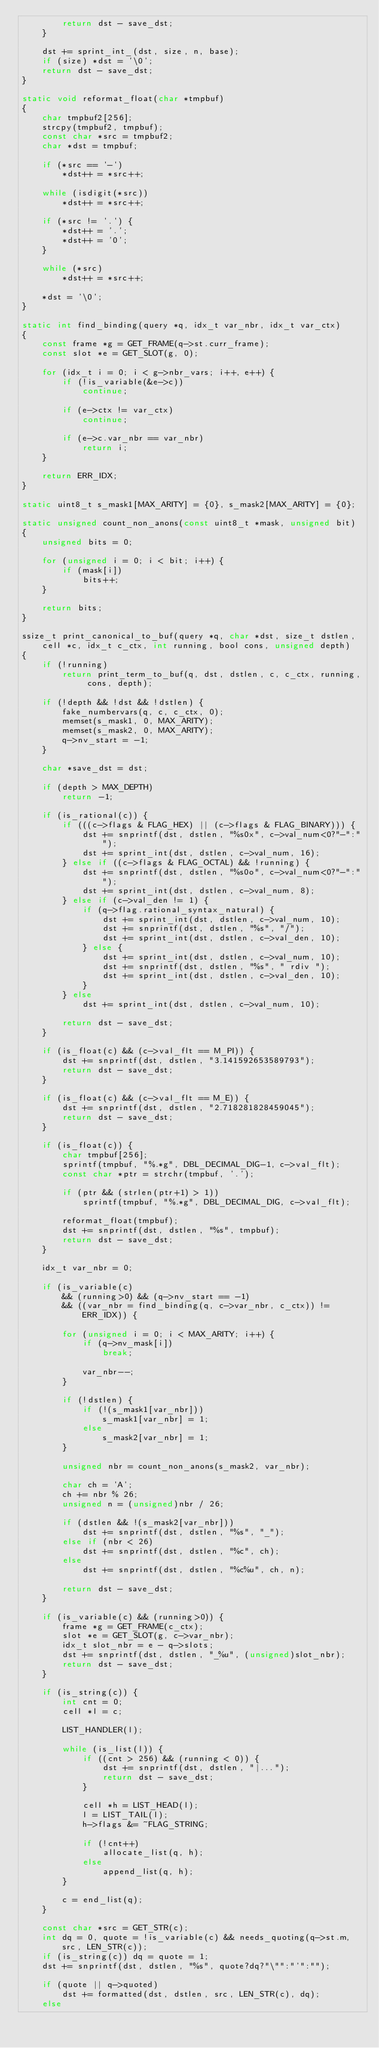<code> <loc_0><loc_0><loc_500><loc_500><_C_>		return dst - save_dst;
	}

	dst += sprint_int_(dst, size, n, base);
	if (size) *dst = '\0';
	return dst - save_dst;
}

static void reformat_float(char *tmpbuf)
{
	char tmpbuf2[256];
	strcpy(tmpbuf2, tmpbuf);
	const char *src = tmpbuf2;
	char *dst = tmpbuf;

	if (*src == '-')
		*dst++ = *src++;

	while (isdigit(*src))
		*dst++ = *src++;

	if (*src != '.') {
		*dst++ = '.';
		*dst++ = '0';
	}

	while (*src)
		*dst++ = *src++;

	*dst = '\0';
}

static int find_binding(query *q, idx_t var_nbr, idx_t var_ctx)
{
	const frame *g = GET_FRAME(q->st.curr_frame);
	const slot *e = GET_SLOT(g, 0);

	for (idx_t i = 0; i < g->nbr_vars; i++, e++) {
		if (!is_variable(&e->c))
			continue;

		if (e->ctx != var_ctx)
			continue;

		if (e->c.var_nbr == var_nbr)
			return i;
	}

	return ERR_IDX;
}

static uint8_t s_mask1[MAX_ARITY] = {0}, s_mask2[MAX_ARITY] = {0};

static unsigned count_non_anons(const uint8_t *mask, unsigned bit)
{
	unsigned bits = 0;

	for (unsigned i = 0; i < bit; i++) {
		if (mask[i])
			bits++;
	}

	return bits;
}

ssize_t print_canonical_to_buf(query *q, char *dst, size_t dstlen, cell *c, idx_t c_ctx, int running, bool cons, unsigned depth)
{
	if (!running)
		return print_term_to_buf(q, dst, dstlen, c, c_ctx, running, cons, depth);

	if (!depth && !dst && !dstlen) {
		fake_numbervars(q, c, c_ctx, 0);
		memset(s_mask1, 0, MAX_ARITY);
		memset(s_mask2, 0, MAX_ARITY);
		q->nv_start = -1;
	}

	char *save_dst = dst;

	if (depth > MAX_DEPTH)
		return -1;

	if (is_rational(c)) {
		if (((c->flags & FLAG_HEX) || (c->flags & FLAG_BINARY))) {
			dst += snprintf(dst, dstlen, "%s0x", c->val_num<0?"-":"");
			dst += sprint_int(dst, dstlen, c->val_num, 16);
		} else if ((c->flags & FLAG_OCTAL) && !running) {
			dst += snprintf(dst, dstlen, "%s0o", c->val_num<0?"-":"");
			dst += sprint_int(dst, dstlen, c->val_num, 8);
		} else if (c->val_den != 1) {
			if (q->flag.rational_syntax_natural) {
				dst += sprint_int(dst, dstlen, c->val_num, 10);
				dst += snprintf(dst, dstlen, "%s", "/");
				dst += sprint_int(dst, dstlen, c->val_den, 10);
			} else {
				dst += sprint_int(dst, dstlen, c->val_num, 10);
				dst += snprintf(dst, dstlen, "%s", " rdiv ");
				dst += sprint_int(dst, dstlen, c->val_den, 10);
			}
		} else
			dst += sprint_int(dst, dstlen, c->val_num, 10);

		return dst - save_dst;
	}

	if (is_float(c) && (c->val_flt == M_PI)) {
		dst += snprintf(dst, dstlen, "3.141592653589793");
		return dst - save_dst;
	}

	if (is_float(c) && (c->val_flt == M_E)) {
		dst += snprintf(dst, dstlen, "2.718281828459045");
		return dst - save_dst;
	}

	if (is_float(c)) {
		char tmpbuf[256];
		sprintf(tmpbuf, "%.*g", DBL_DECIMAL_DIG-1, c->val_flt);
		const char *ptr = strchr(tmpbuf, '.');

		if (ptr && (strlen(ptr+1) > 1))
			sprintf(tmpbuf, "%.*g", DBL_DECIMAL_DIG, c->val_flt);

		reformat_float(tmpbuf);
		dst += snprintf(dst, dstlen, "%s", tmpbuf);
		return dst - save_dst;
	}

	idx_t var_nbr = 0;

	if (is_variable(c)
		&& (running>0) && (q->nv_start == -1)
		&& ((var_nbr = find_binding(q, c->var_nbr, c_ctx)) != ERR_IDX)) {

		for (unsigned i = 0; i < MAX_ARITY; i++) {
			if (q->nv_mask[i])
				break;

			var_nbr--;
		}

		if (!dstlen) {
			if (!(s_mask1[var_nbr]))
				s_mask1[var_nbr] = 1;
			else
				s_mask2[var_nbr] = 1;
		}

		unsigned nbr = count_non_anons(s_mask2, var_nbr);

		char ch = 'A';
		ch += nbr % 26;
		unsigned n = (unsigned)nbr / 26;

		if (dstlen && !(s_mask2[var_nbr]))
			dst += snprintf(dst, dstlen, "%s", "_");
		else if (nbr < 26)
			dst += snprintf(dst, dstlen, "%c", ch);
		else
			dst += snprintf(dst, dstlen, "%c%u", ch, n);

		return dst - save_dst;
	}

	if (is_variable(c) && (running>0)) {
		frame *g = GET_FRAME(c_ctx);
		slot *e = GET_SLOT(g, c->var_nbr);
		idx_t slot_nbr = e - q->slots;
		dst += snprintf(dst, dstlen, "_%u", (unsigned)slot_nbr);
		return dst - save_dst;
	}

	if (is_string(c)) {
		int cnt = 0;
		cell *l = c;

		LIST_HANDLER(l);

		while (is_list(l)) {
			if ((cnt > 256) && (running < 0)) {
				dst += snprintf(dst, dstlen, "|...");
				return dst - save_dst;
			}

			cell *h = LIST_HEAD(l);
			l = LIST_TAIL(l);
			h->flags &= ~FLAG_STRING;

			if (!cnt++)
				allocate_list(q, h);
			else
				append_list(q, h);
		}

		c = end_list(q);
	}

	const char *src = GET_STR(c);
	int dq = 0, quote = !is_variable(c) && needs_quoting(q->st.m, src, LEN_STR(c));
	if (is_string(c)) dq = quote = 1;
	dst += snprintf(dst, dstlen, "%s", quote?dq?"\"":"'":"");

	if (quote || q->quoted)
		dst += formatted(dst, dstlen, src, LEN_STR(c), dq);
	else</code> 